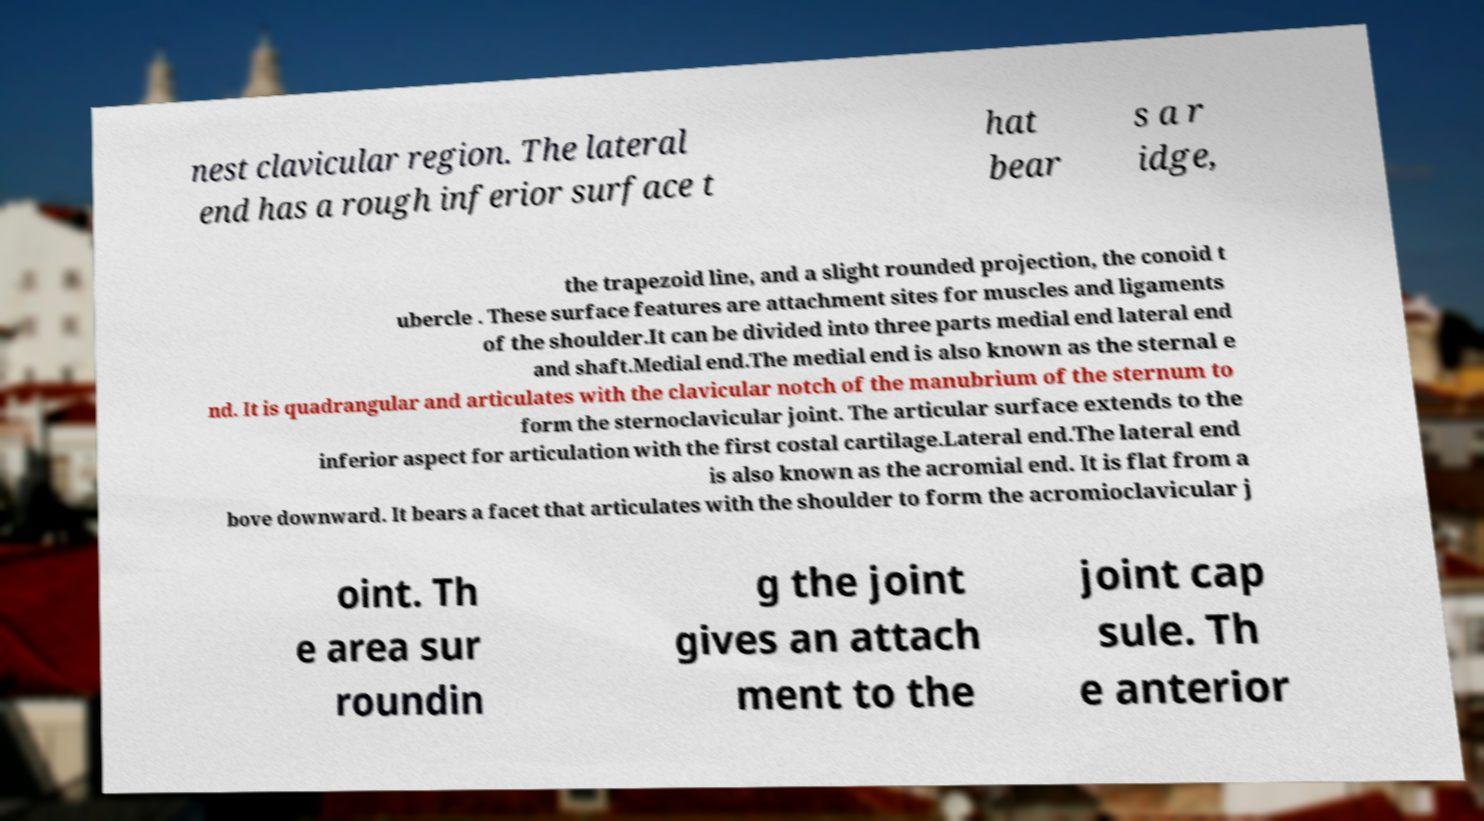Can you accurately transcribe the text from the provided image for me? nest clavicular region. The lateral end has a rough inferior surface t hat bear s a r idge, the trapezoid line, and a slight rounded projection, the conoid t ubercle . These surface features are attachment sites for muscles and ligaments of the shoulder.It can be divided into three parts medial end lateral end and shaft.Medial end.The medial end is also known as the sternal e nd. It is quadrangular and articulates with the clavicular notch of the manubrium of the sternum to form the sternoclavicular joint. The articular surface extends to the inferior aspect for articulation with the first costal cartilage.Lateral end.The lateral end is also known as the acromial end. It is flat from a bove downward. It bears a facet that articulates with the shoulder to form the acromioclavicular j oint. Th e area sur roundin g the joint gives an attach ment to the joint cap sule. Th e anterior 